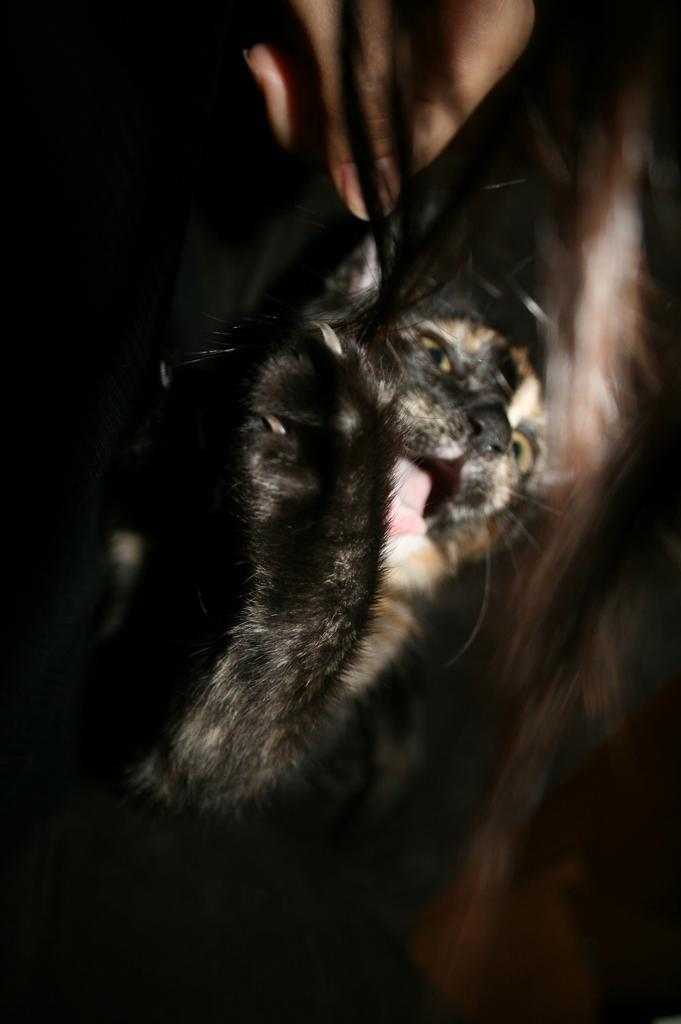What type of animal is present in the image? There is an animal in the image, but the specific type of animal is not mentioned in the provided facts. What can be said about the background of the image? The background of the image is dark. What news is the animal discussing with the system in the image? There is no indication in the image that the animal is discussing news with a system, as the provided facts do not mention any such interaction. 